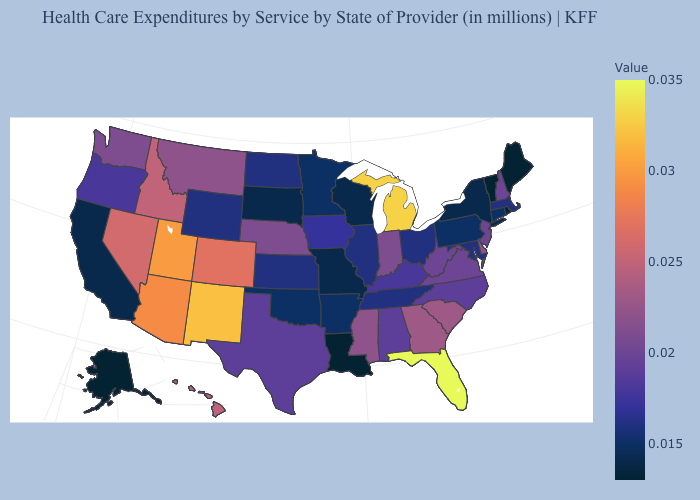Which states hav the highest value in the Northeast?
Answer briefly. New Hampshire, New Jersey. Among the states that border Florida , which have the highest value?
Answer briefly. Georgia. Does Florida have the highest value in the USA?
Short answer required. Yes. Which states hav the highest value in the South?
Answer briefly. Florida. 